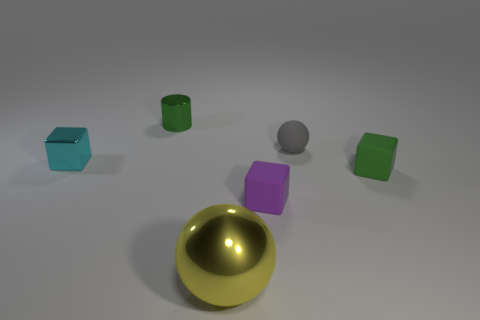What color is the block on the right side of the rubber ball?
Your answer should be very brief. Green. There is a small cube that is the same color as the tiny metallic cylinder; what is it made of?
Your answer should be very brief. Rubber. There is a green cylinder; are there any purple things to the right of it?
Offer a terse response. Yes. Is the number of tiny green shiny objects greater than the number of small blue matte cylinders?
Offer a terse response. Yes. There is a small rubber block behind the tiny object in front of the tiny green object right of the large metal ball; what is its color?
Offer a very short reply. Green. What color is the cylinder that is the same material as the yellow ball?
Provide a succinct answer. Green. Are there any other things that have the same size as the gray ball?
Your answer should be compact. Yes. How many objects are small objects in front of the green matte object or metallic things in front of the purple block?
Provide a succinct answer. 2. Does the metal object that is behind the tiny cyan shiny cube have the same size as the block that is in front of the green matte cube?
Offer a very short reply. Yes. What is the color of the small metal thing that is the same shape as the small purple matte object?
Offer a very short reply. Cyan. 